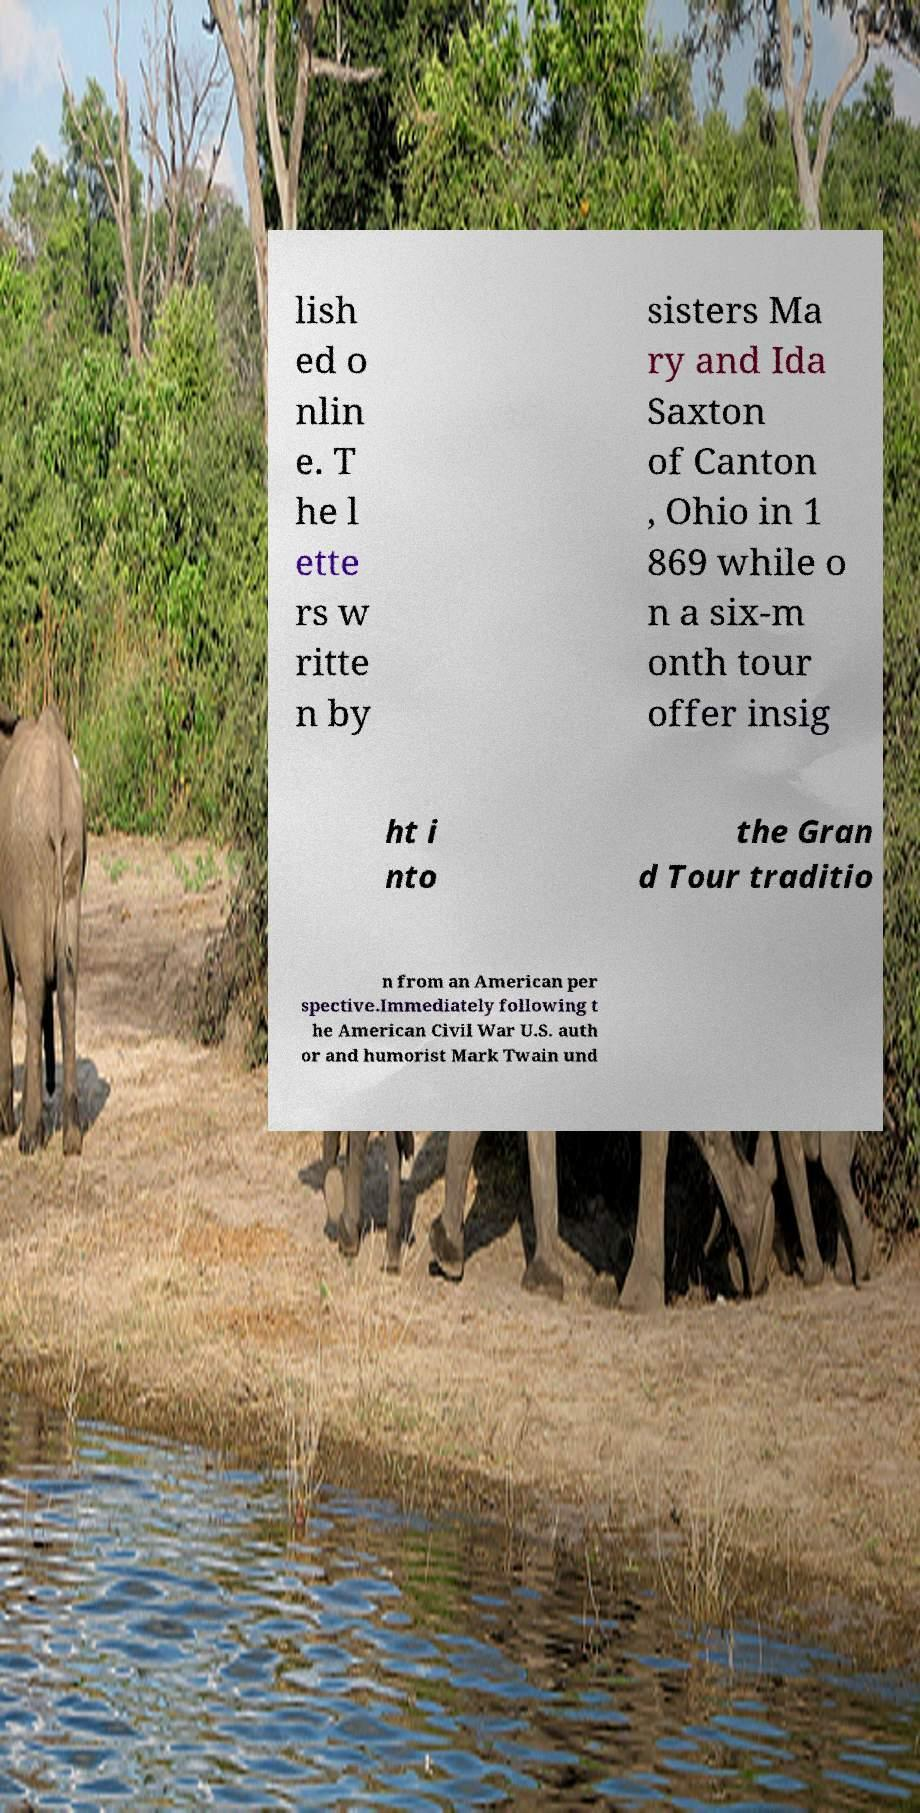What messages or text are displayed in this image? I need them in a readable, typed format. lish ed o nlin e. T he l ette rs w ritte n by sisters Ma ry and Ida Saxton of Canton , Ohio in 1 869 while o n a six-m onth tour offer insig ht i nto the Gran d Tour traditio n from an American per spective.Immediately following t he American Civil War U.S. auth or and humorist Mark Twain und 